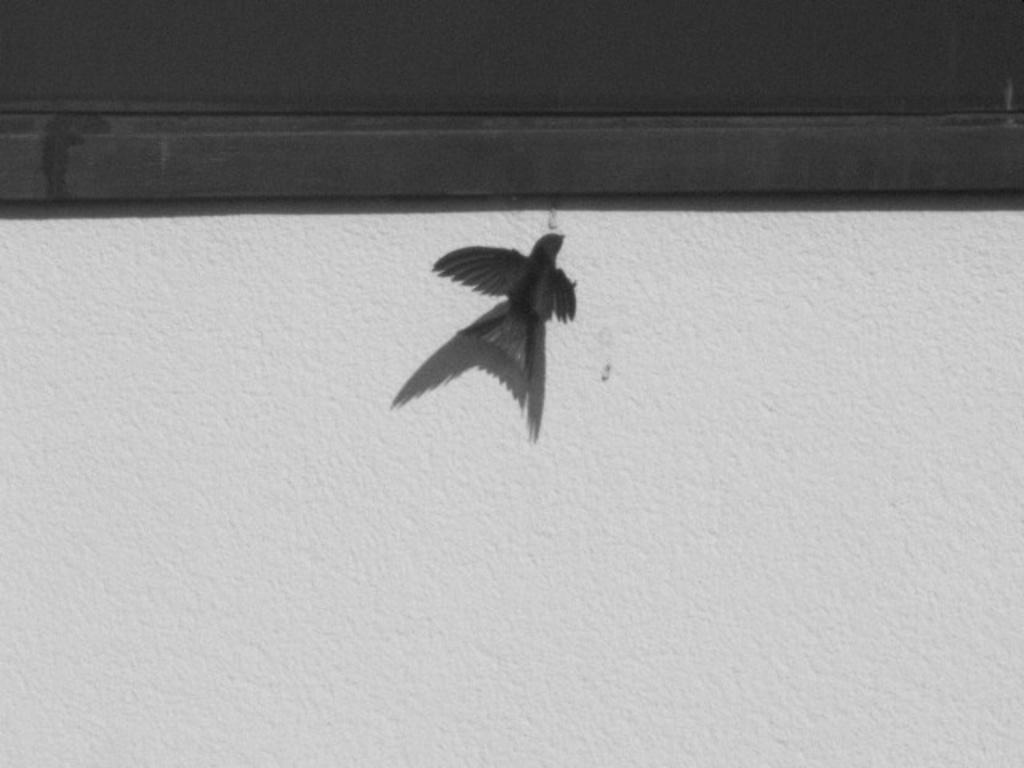What is depicted on the wall in the image? There is a bird represented on the wall in the image. What type of beef is being offered to the bird on the wall in the image? There is no beef present in the image, and the bird is a representation, not a living creature. 